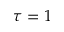<formula> <loc_0><loc_0><loc_500><loc_500>\tau = 1</formula> 